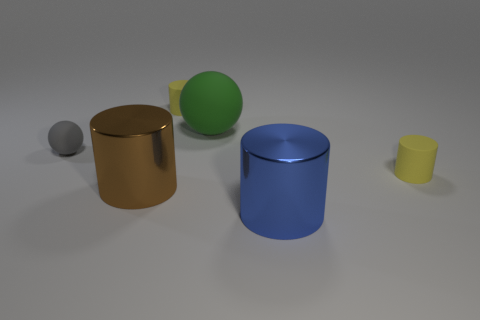Add 2 small gray rubber balls. How many objects exist? 8 Subtract all balls. How many objects are left? 4 Subtract 1 green spheres. How many objects are left? 5 Subtract all large brown rubber balls. Subtract all small yellow cylinders. How many objects are left? 4 Add 5 gray matte spheres. How many gray matte spheres are left? 6 Add 4 big brown matte cylinders. How many big brown matte cylinders exist? 4 